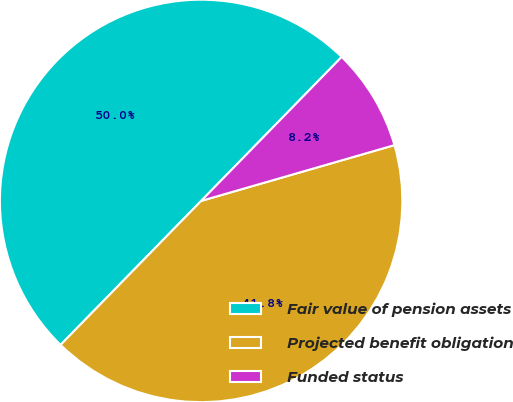<chart> <loc_0><loc_0><loc_500><loc_500><pie_chart><fcel>Fair value of pension assets<fcel>Projected benefit obligation<fcel>Funded status<nl><fcel>50.0%<fcel>41.78%<fcel>8.22%<nl></chart> 